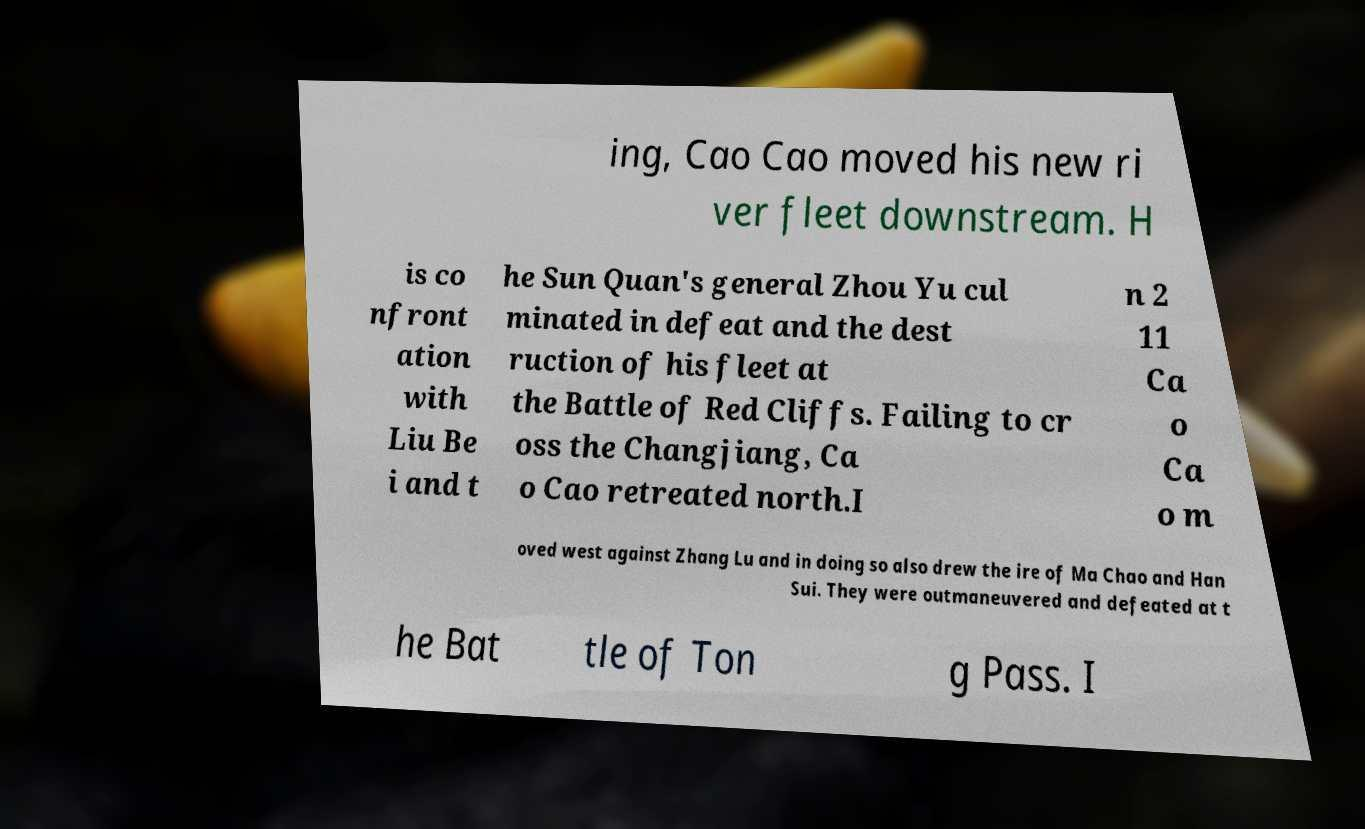Please read and relay the text visible in this image. What does it say? ing, Cao Cao moved his new ri ver fleet downstream. H is co nfront ation with Liu Be i and t he Sun Quan's general Zhou Yu cul minated in defeat and the dest ruction of his fleet at the Battle of Red Cliffs. Failing to cr oss the Changjiang, Ca o Cao retreated north.I n 2 11 Ca o Ca o m oved west against Zhang Lu and in doing so also drew the ire of Ma Chao and Han Sui. They were outmaneuvered and defeated at t he Bat tle of Ton g Pass. I 